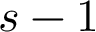<formula> <loc_0><loc_0><loc_500><loc_500>s - 1</formula> 